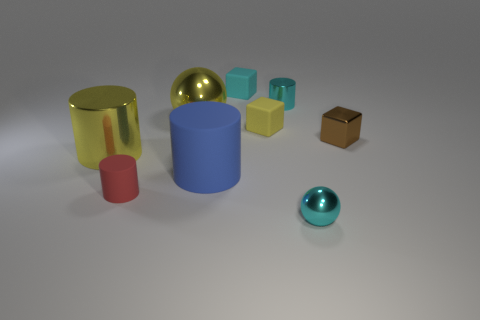Subtract all cubes. How many objects are left? 6 Add 6 cyan matte balls. How many cyan matte balls exist? 6 Subtract 0 gray cylinders. How many objects are left? 9 Subtract all large shiny cylinders. Subtract all small cyan things. How many objects are left? 5 Add 4 yellow things. How many yellow things are left? 7 